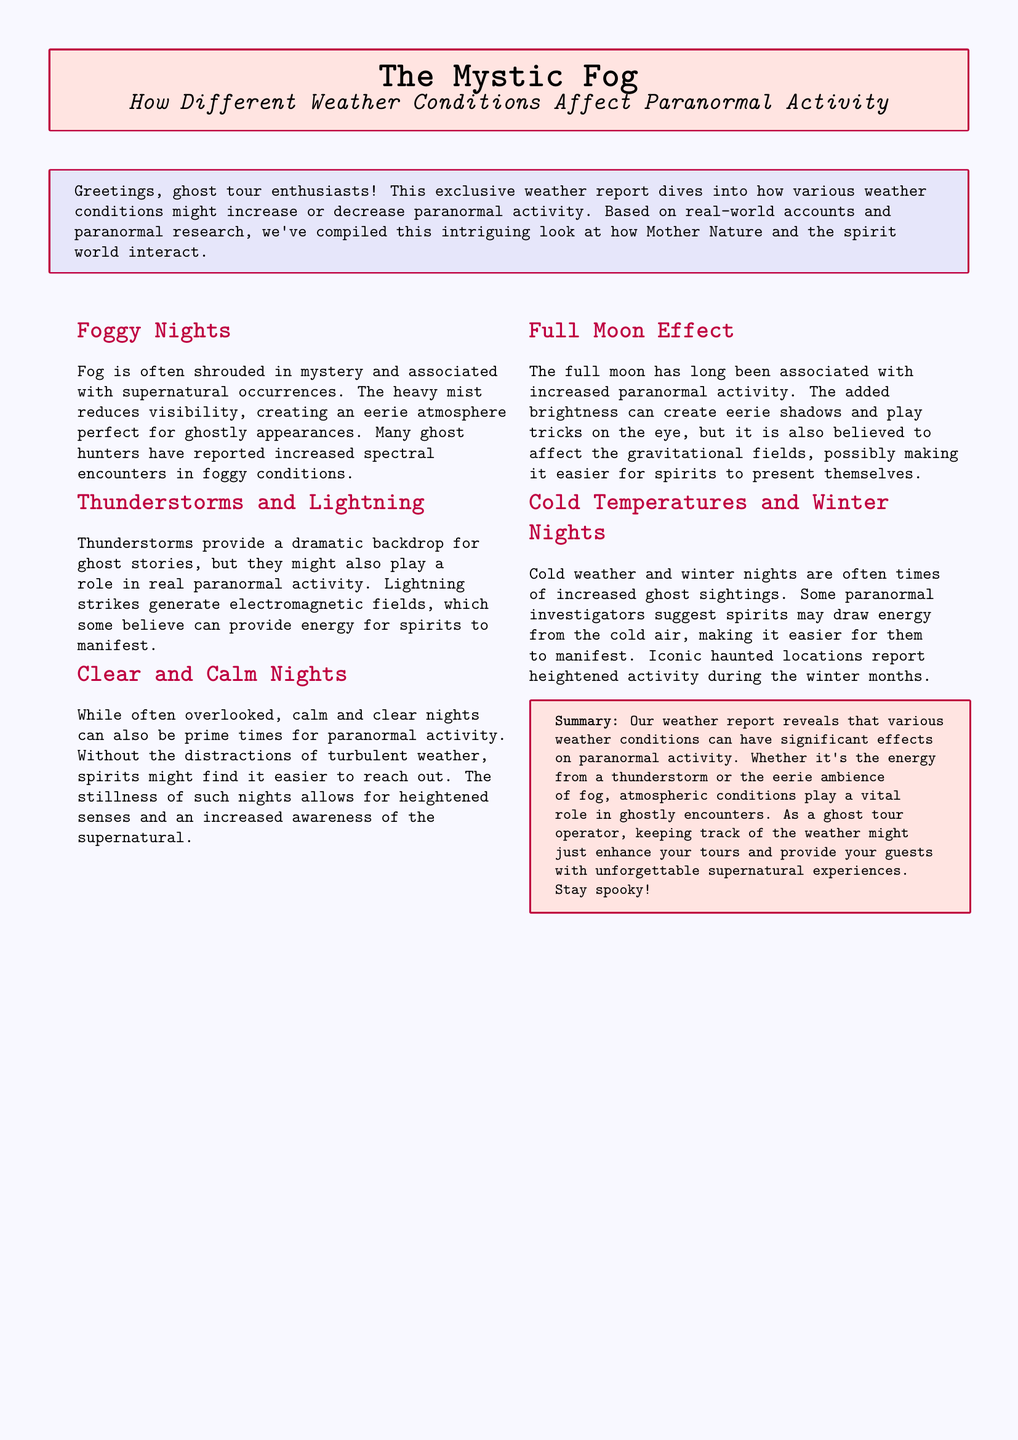What is the main topic of the document? The document discusses how different weather conditions affect paranormal activity.
Answer: Weather conditions and paranormal activity What are the atmospheric conditions associated with increased spectral encounters? The document states that fog creates an eerie atmosphere perfect for ghostly appearances.
Answer: Foggy conditions What phenomenon generates electromagnetic fields during storms? The document mentions that lightning strikes generate electromagnetic fields.
Answer: Lightning What type of night is often overlooked for paranormal activity? Calm and clear nights are mentioned as prime times for paranormal activity.
Answer: Calm and clear nights What celestial event is believed to influence ghostly manifestations? The document states that the full moon is associated with increased paranormal activity.
Answer: Full moon Which season reportedly sees heightened ghost sightings? Cold weather and winter nights are said to have increased ghost sightings.
Answer: Winter What might spirits draw energy from, according to investigators? The document suggests that spirits may draw energy from cold air.
Answer: Cold air How does fog affect visibility? The document notes that heavy mist reduces visibility.
Answer: Reduces visibility What is a common belief about thunderstorms and ghost stories? The document explains that thunderstorms provide a dramatic backdrop for ghost stories.
Answer: Dramatic backdrop 